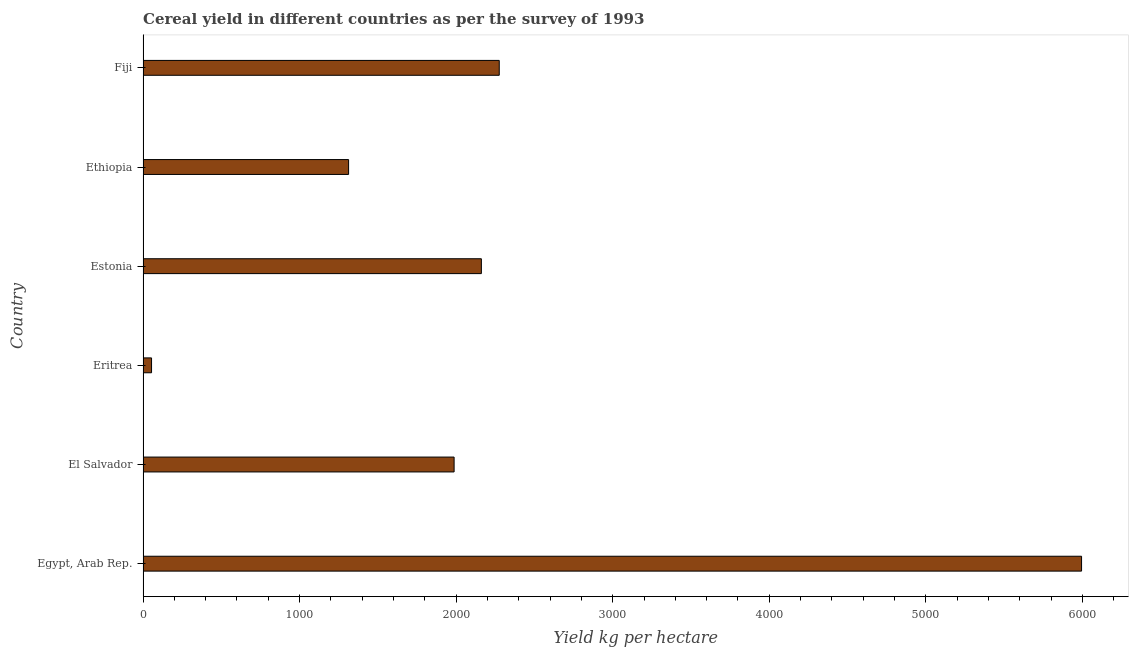Does the graph contain grids?
Offer a terse response. No. What is the title of the graph?
Give a very brief answer. Cereal yield in different countries as per the survey of 1993. What is the label or title of the X-axis?
Your answer should be compact. Yield kg per hectare. What is the cereal yield in Eritrea?
Offer a very short reply. 54.24. Across all countries, what is the maximum cereal yield?
Offer a very short reply. 5995.15. Across all countries, what is the minimum cereal yield?
Give a very brief answer. 54.24. In which country was the cereal yield maximum?
Your answer should be very brief. Egypt, Arab Rep. In which country was the cereal yield minimum?
Make the answer very short. Eritrea. What is the sum of the cereal yield?
Ensure brevity in your answer.  1.38e+04. What is the difference between the cereal yield in Egypt, Arab Rep. and Eritrea?
Give a very brief answer. 5940.91. What is the average cereal yield per country?
Your answer should be compact. 2297.61. What is the median cereal yield?
Make the answer very short. 2074.01. What is the ratio of the cereal yield in Eritrea to that in Estonia?
Offer a terse response. 0.03. What is the difference between the highest and the second highest cereal yield?
Your answer should be very brief. 3719.88. Is the sum of the cereal yield in Eritrea and Ethiopia greater than the maximum cereal yield across all countries?
Make the answer very short. No. What is the difference between the highest and the lowest cereal yield?
Keep it short and to the point. 5940.91. Are all the bars in the graph horizontal?
Provide a short and direct response. Yes. How many countries are there in the graph?
Your answer should be compact. 6. What is the difference between two consecutive major ticks on the X-axis?
Give a very brief answer. 1000. Are the values on the major ticks of X-axis written in scientific E-notation?
Ensure brevity in your answer.  No. What is the Yield kg per hectare in Egypt, Arab Rep.?
Make the answer very short. 5995.15. What is the Yield kg per hectare of El Salvador?
Your response must be concise. 1986.92. What is the Yield kg per hectare of Eritrea?
Ensure brevity in your answer.  54.24. What is the Yield kg per hectare in Estonia?
Give a very brief answer. 2161.09. What is the Yield kg per hectare of Ethiopia?
Make the answer very short. 1312.97. What is the Yield kg per hectare in Fiji?
Your response must be concise. 2275.27. What is the difference between the Yield kg per hectare in Egypt, Arab Rep. and El Salvador?
Keep it short and to the point. 4008.23. What is the difference between the Yield kg per hectare in Egypt, Arab Rep. and Eritrea?
Provide a short and direct response. 5940.91. What is the difference between the Yield kg per hectare in Egypt, Arab Rep. and Estonia?
Offer a terse response. 3834.06. What is the difference between the Yield kg per hectare in Egypt, Arab Rep. and Ethiopia?
Make the answer very short. 4682.18. What is the difference between the Yield kg per hectare in Egypt, Arab Rep. and Fiji?
Offer a very short reply. 3719.88. What is the difference between the Yield kg per hectare in El Salvador and Eritrea?
Provide a succinct answer. 1932.68. What is the difference between the Yield kg per hectare in El Salvador and Estonia?
Ensure brevity in your answer.  -174.17. What is the difference between the Yield kg per hectare in El Salvador and Ethiopia?
Offer a very short reply. 673.95. What is the difference between the Yield kg per hectare in El Salvador and Fiji?
Provide a short and direct response. -288.35. What is the difference between the Yield kg per hectare in Eritrea and Estonia?
Give a very brief answer. -2106.85. What is the difference between the Yield kg per hectare in Eritrea and Ethiopia?
Give a very brief answer. -1258.73. What is the difference between the Yield kg per hectare in Eritrea and Fiji?
Make the answer very short. -2221.03. What is the difference between the Yield kg per hectare in Estonia and Ethiopia?
Give a very brief answer. 848.12. What is the difference between the Yield kg per hectare in Estonia and Fiji?
Offer a terse response. -114.18. What is the difference between the Yield kg per hectare in Ethiopia and Fiji?
Offer a terse response. -962.3. What is the ratio of the Yield kg per hectare in Egypt, Arab Rep. to that in El Salvador?
Offer a terse response. 3.02. What is the ratio of the Yield kg per hectare in Egypt, Arab Rep. to that in Eritrea?
Your answer should be very brief. 110.53. What is the ratio of the Yield kg per hectare in Egypt, Arab Rep. to that in Estonia?
Offer a terse response. 2.77. What is the ratio of the Yield kg per hectare in Egypt, Arab Rep. to that in Ethiopia?
Your answer should be very brief. 4.57. What is the ratio of the Yield kg per hectare in Egypt, Arab Rep. to that in Fiji?
Give a very brief answer. 2.63. What is the ratio of the Yield kg per hectare in El Salvador to that in Eritrea?
Your answer should be compact. 36.63. What is the ratio of the Yield kg per hectare in El Salvador to that in Estonia?
Provide a succinct answer. 0.92. What is the ratio of the Yield kg per hectare in El Salvador to that in Ethiopia?
Offer a terse response. 1.51. What is the ratio of the Yield kg per hectare in El Salvador to that in Fiji?
Ensure brevity in your answer.  0.87. What is the ratio of the Yield kg per hectare in Eritrea to that in Estonia?
Make the answer very short. 0.03. What is the ratio of the Yield kg per hectare in Eritrea to that in Ethiopia?
Offer a terse response. 0.04. What is the ratio of the Yield kg per hectare in Eritrea to that in Fiji?
Give a very brief answer. 0.02. What is the ratio of the Yield kg per hectare in Estonia to that in Ethiopia?
Offer a terse response. 1.65. What is the ratio of the Yield kg per hectare in Estonia to that in Fiji?
Give a very brief answer. 0.95. What is the ratio of the Yield kg per hectare in Ethiopia to that in Fiji?
Your answer should be very brief. 0.58. 